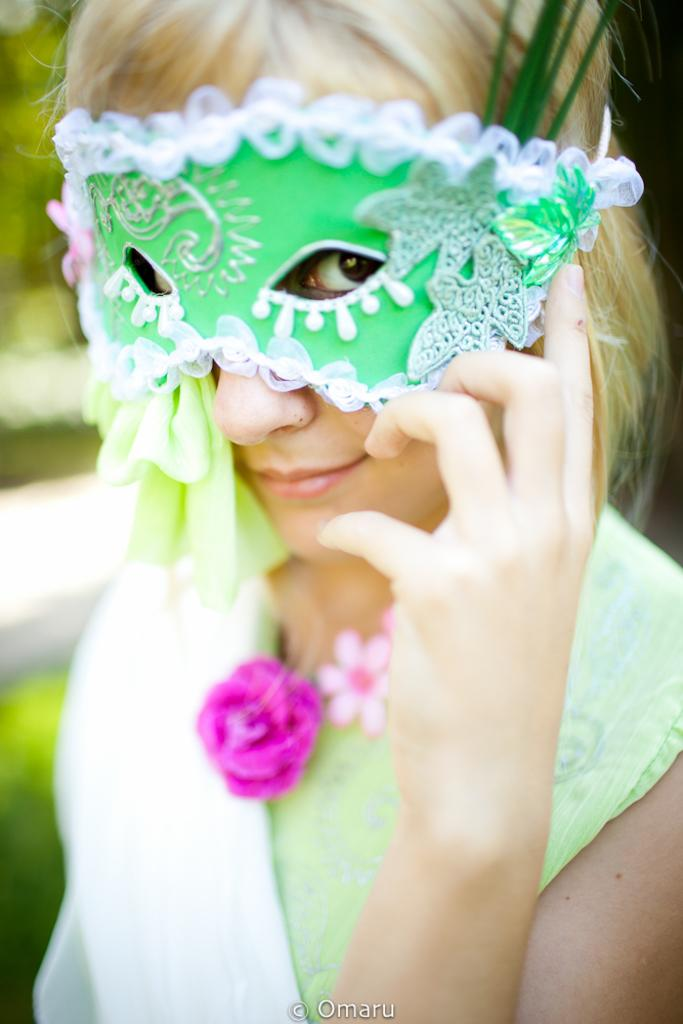Who is the main subject in the image? There is a woman in the image. What is the woman wearing? The woman is wearing a green dress and a mask. Can you describe the background of the image? The background of the image is blurred. What type of apple can be seen on the floor in the image? There is no apple present on the floor in the image. Can you describe the woman's smile in the image? The woman is wearing a mask, so it is not possible to see her smile in the image. 